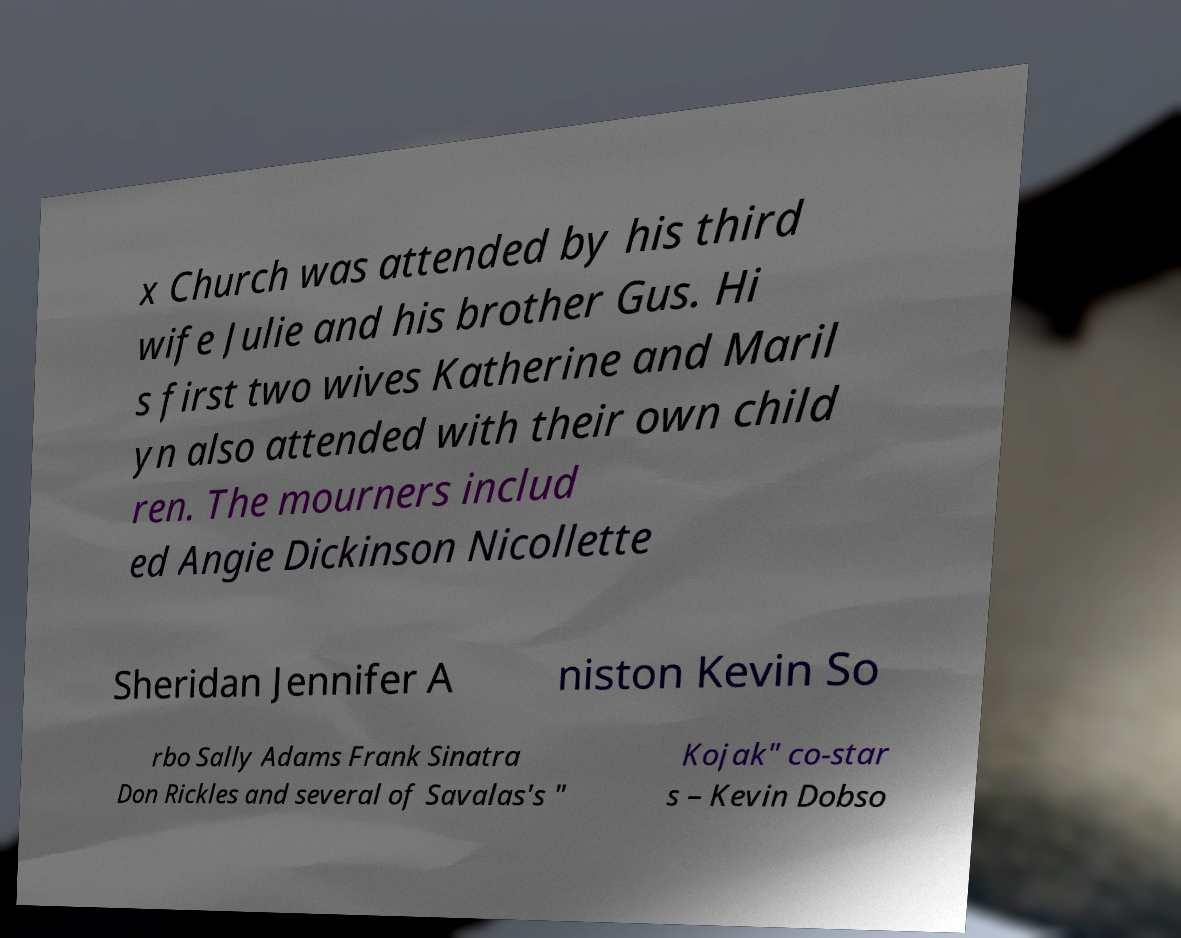Please read and relay the text visible in this image. What does it say? x Church was attended by his third wife Julie and his brother Gus. Hi s first two wives Katherine and Maril yn also attended with their own child ren. The mourners includ ed Angie Dickinson Nicollette Sheridan Jennifer A niston Kevin So rbo Sally Adams Frank Sinatra Don Rickles and several of Savalas's " Kojak" co-star s – Kevin Dobso 